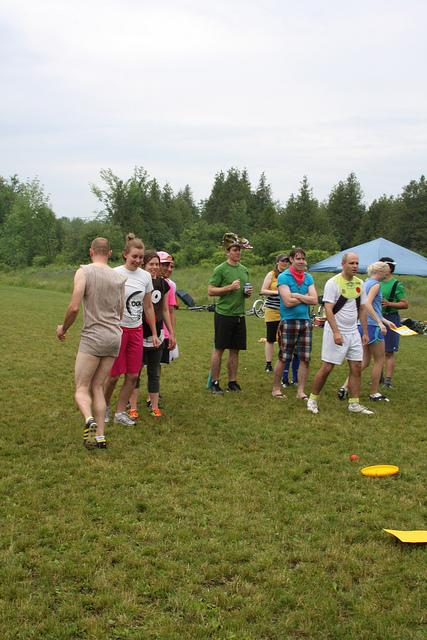Where are they playing a game?

Choices:
A) beach
B) park
C) stadium
D) gym park 